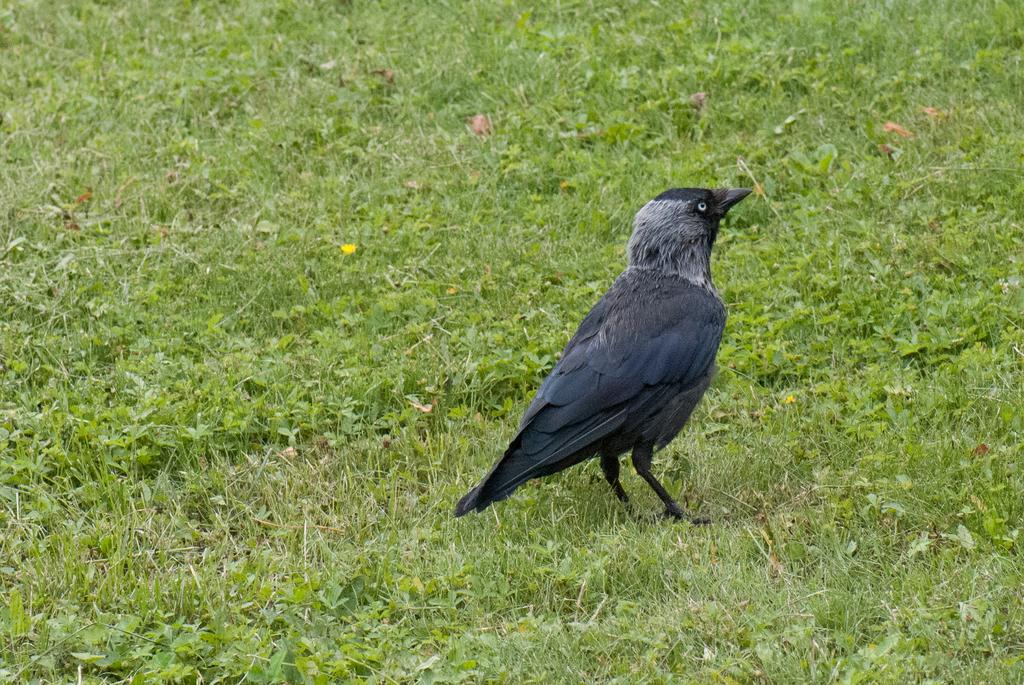What type of bird is in the image? There is a crow in the image. Where is the crow located in the image? The crow is standing on the ground. What type of vegetation is present in the image? There is green grass in the image. What else can be seen in the image besides the crow and grass? There are leaves in the image. What type of hole can be seen in the image? There is no hole present in the image. 